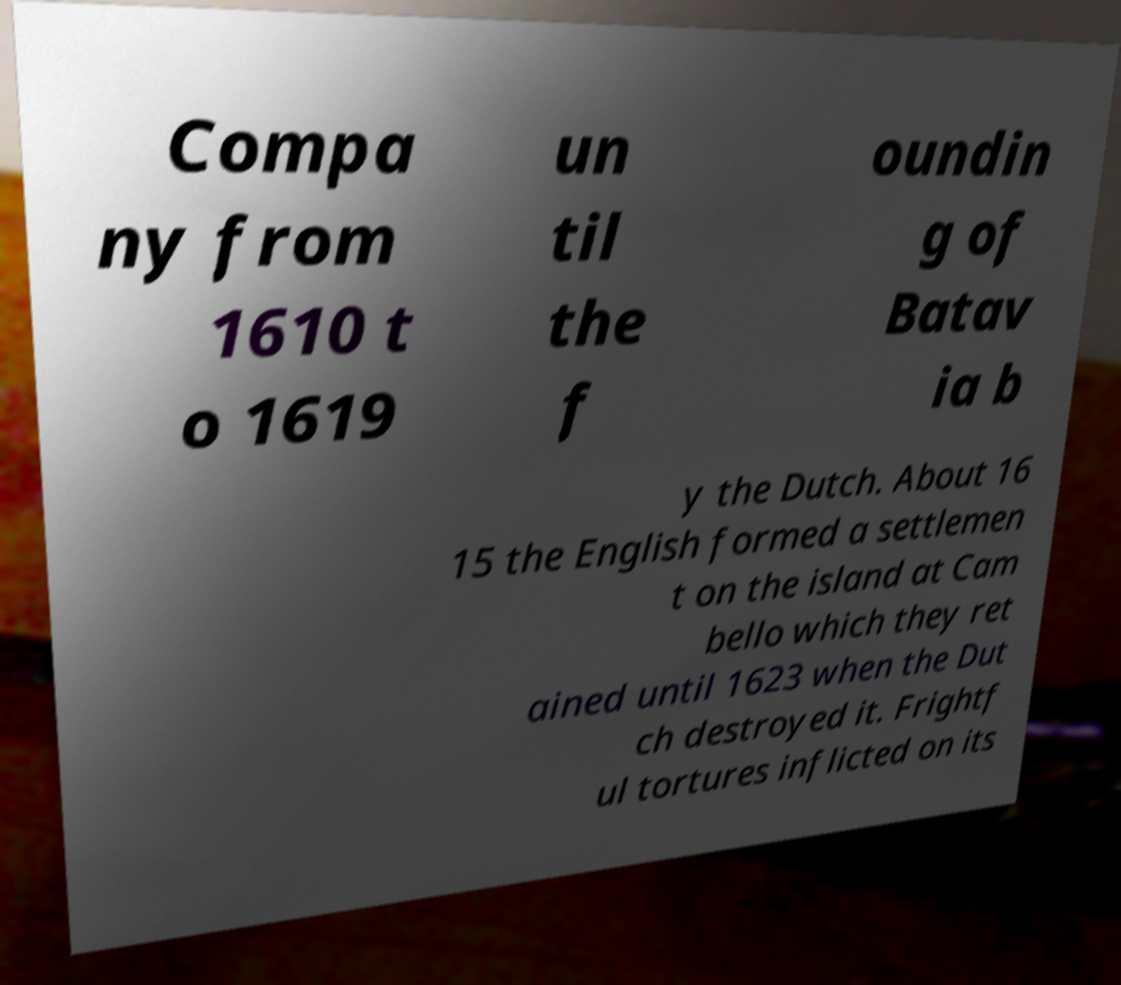There's text embedded in this image that I need extracted. Can you transcribe it verbatim? Compa ny from 1610 t o 1619 un til the f oundin g of Batav ia b y the Dutch. About 16 15 the English formed a settlemen t on the island at Cam bello which they ret ained until 1623 when the Dut ch destroyed it. Frightf ul tortures inflicted on its 